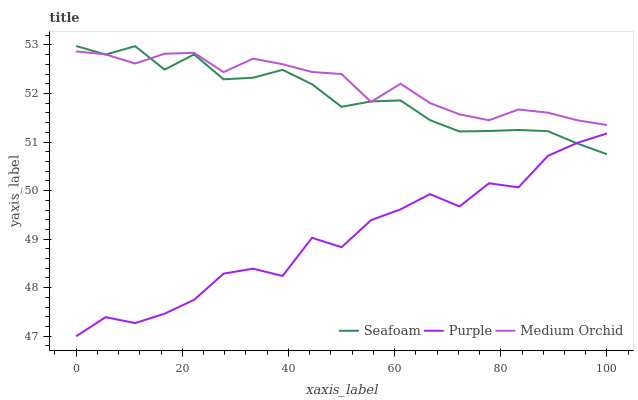Does Seafoam have the minimum area under the curve?
Answer yes or no. No. Does Seafoam have the maximum area under the curve?
Answer yes or no. No. Is Seafoam the smoothest?
Answer yes or no. No. Is Seafoam the roughest?
Answer yes or no. No. Does Seafoam have the lowest value?
Answer yes or no. No. Does Medium Orchid have the highest value?
Answer yes or no. No. Is Purple less than Medium Orchid?
Answer yes or no. Yes. Is Medium Orchid greater than Purple?
Answer yes or no. Yes. Does Purple intersect Medium Orchid?
Answer yes or no. No. 